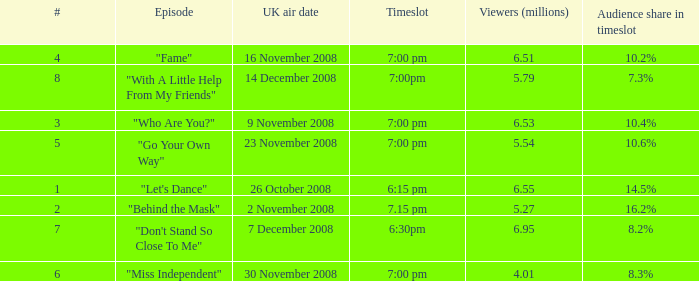Name the total number of viewers for audience share in timeslot for 10.2% 1.0. 